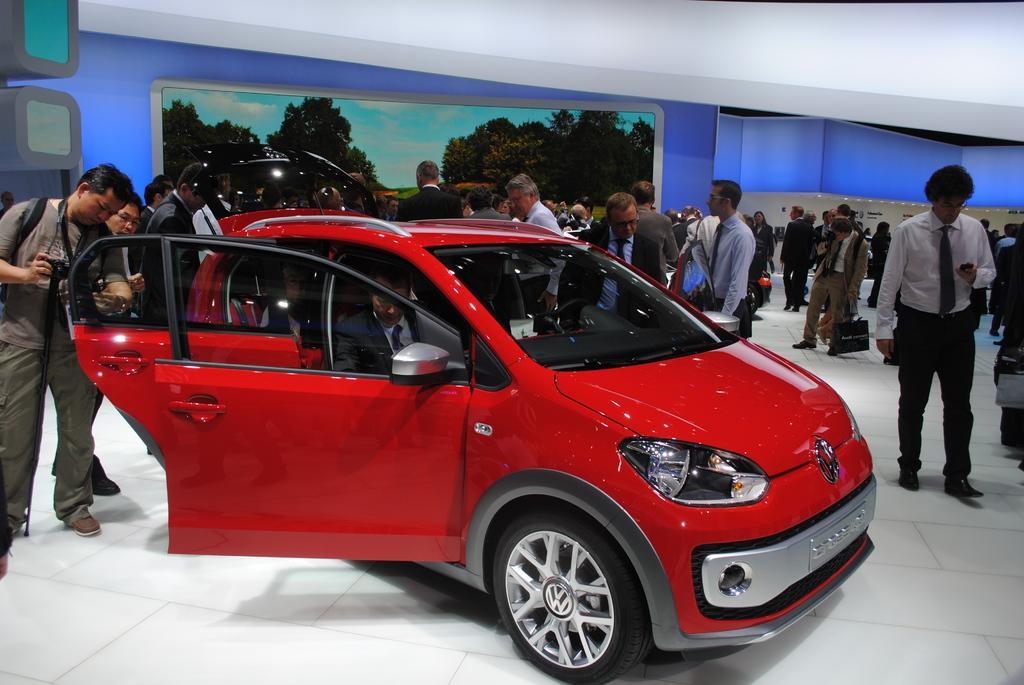In one or two sentences, can you explain what this image depicts? There are group of people who are attended to visit the Volkswagen car and the person at the right side operating his phone and a person seated on a driver seat watching out the features of the car and at the left side of the image a man carrying a backpack and holding a camera looking at the window glass and there is a scenery at the back end and at the background there is a blue color ceiling wall and here is a person who holding a carry bag 